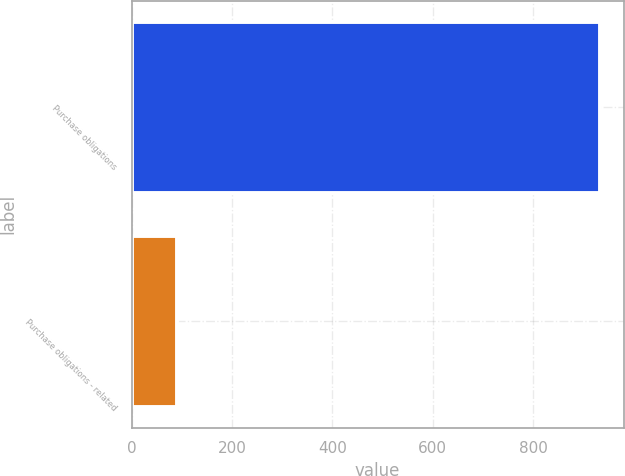<chart> <loc_0><loc_0><loc_500><loc_500><bar_chart><fcel>Purchase obligations<fcel>Purchase obligations - related<nl><fcel>934<fcel>91<nl></chart> 